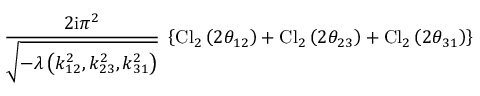<formula> <loc_0><loc_0><loc_500><loc_500>\frac { 2 i \pi ^ { 2 } } { \sqrt { - \lambda \left ( k _ { 1 2 } ^ { 2 } , k _ { 2 3 } ^ { 2 } , k _ { 3 1 } ^ { 2 } \right ) } } \, \left \{ C l _ { 2 } \left ( 2 \theta _ { 1 2 } \right ) + C l _ { 2 } \left ( 2 \theta _ { 2 3 } \right ) + C l _ { 2 } \left ( 2 \theta _ { 3 1 } \right ) \right \}</formula> 